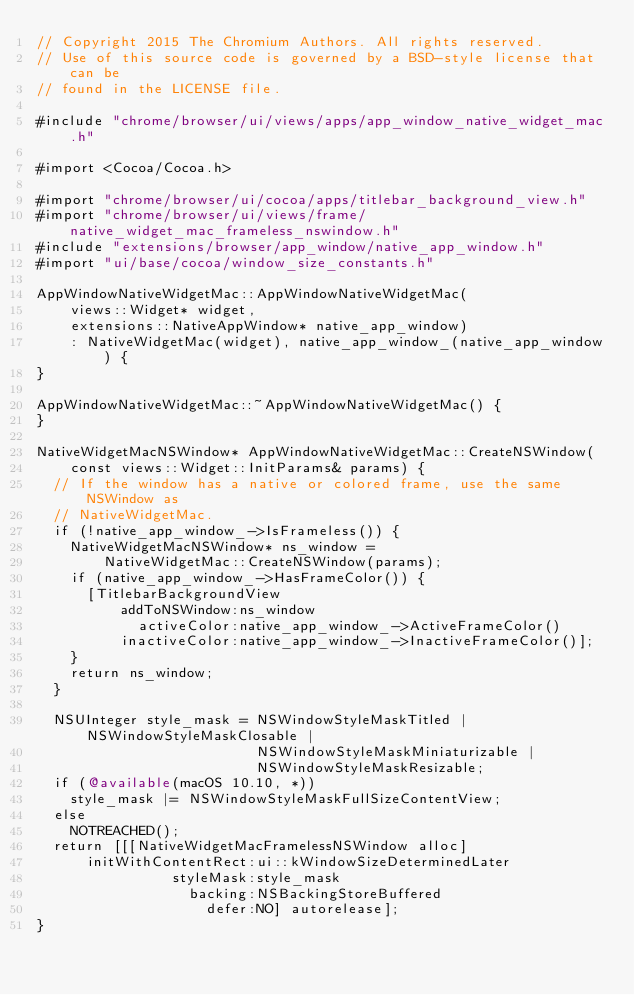<code> <loc_0><loc_0><loc_500><loc_500><_ObjectiveC_>// Copyright 2015 The Chromium Authors. All rights reserved.
// Use of this source code is governed by a BSD-style license that can be
// found in the LICENSE file.

#include "chrome/browser/ui/views/apps/app_window_native_widget_mac.h"

#import <Cocoa/Cocoa.h>

#import "chrome/browser/ui/cocoa/apps/titlebar_background_view.h"
#import "chrome/browser/ui/views/frame/native_widget_mac_frameless_nswindow.h"
#include "extensions/browser/app_window/native_app_window.h"
#import "ui/base/cocoa/window_size_constants.h"

AppWindowNativeWidgetMac::AppWindowNativeWidgetMac(
    views::Widget* widget,
    extensions::NativeAppWindow* native_app_window)
    : NativeWidgetMac(widget), native_app_window_(native_app_window) {
}

AppWindowNativeWidgetMac::~AppWindowNativeWidgetMac() {
}

NativeWidgetMacNSWindow* AppWindowNativeWidgetMac::CreateNSWindow(
    const views::Widget::InitParams& params) {
  // If the window has a native or colored frame, use the same NSWindow as
  // NativeWidgetMac.
  if (!native_app_window_->IsFrameless()) {
    NativeWidgetMacNSWindow* ns_window =
        NativeWidgetMac::CreateNSWindow(params);
    if (native_app_window_->HasFrameColor()) {
      [TitlebarBackgroundView
          addToNSWindow:ns_window
            activeColor:native_app_window_->ActiveFrameColor()
          inactiveColor:native_app_window_->InactiveFrameColor()];
    }
    return ns_window;
  }

  NSUInteger style_mask = NSWindowStyleMaskTitled | NSWindowStyleMaskClosable |
                          NSWindowStyleMaskMiniaturizable |
                          NSWindowStyleMaskResizable;
  if (@available(macOS 10.10, *))
    style_mask |= NSWindowStyleMaskFullSizeContentView;
  else
    NOTREACHED();
  return [[[NativeWidgetMacFramelessNSWindow alloc]
      initWithContentRect:ui::kWindowSizeDeterminedLater
                styleMask:style_mask
                  backing:NSBackingStoreBuffered
                    defer:NO] autorelease];
}
</code> 